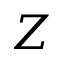Convert formula to latex. <formula><loc_0><loc_0><loc_500><loc_500>Z</formula> 